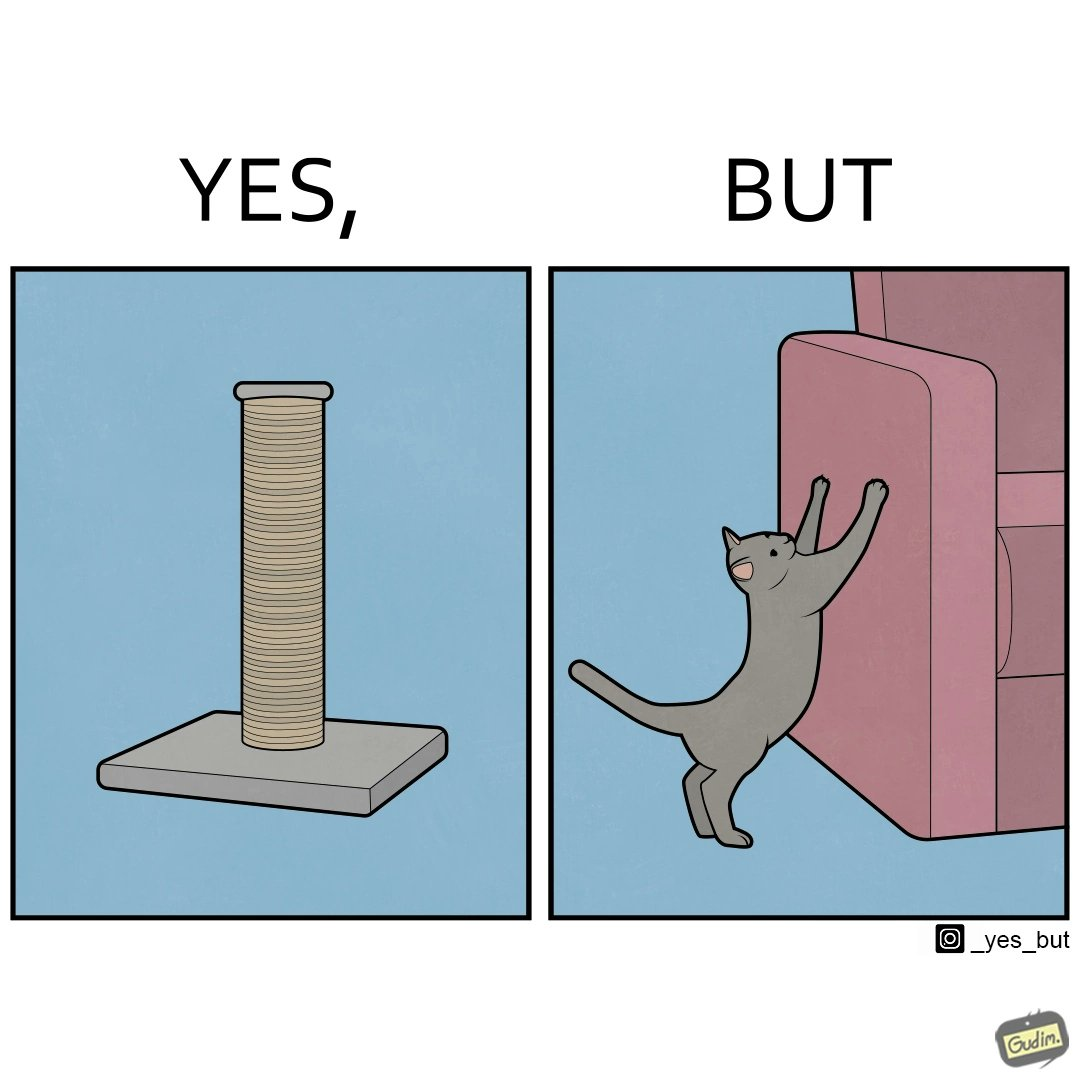Does this image contain satire or humor? Yes, this image is satirical. 